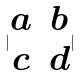Convert formula to latex. <formula><loc_0><loc_0><loc_500><loc_500>| \begin{matrix} a & b \\ c & d \end{matrix} |</formula> 